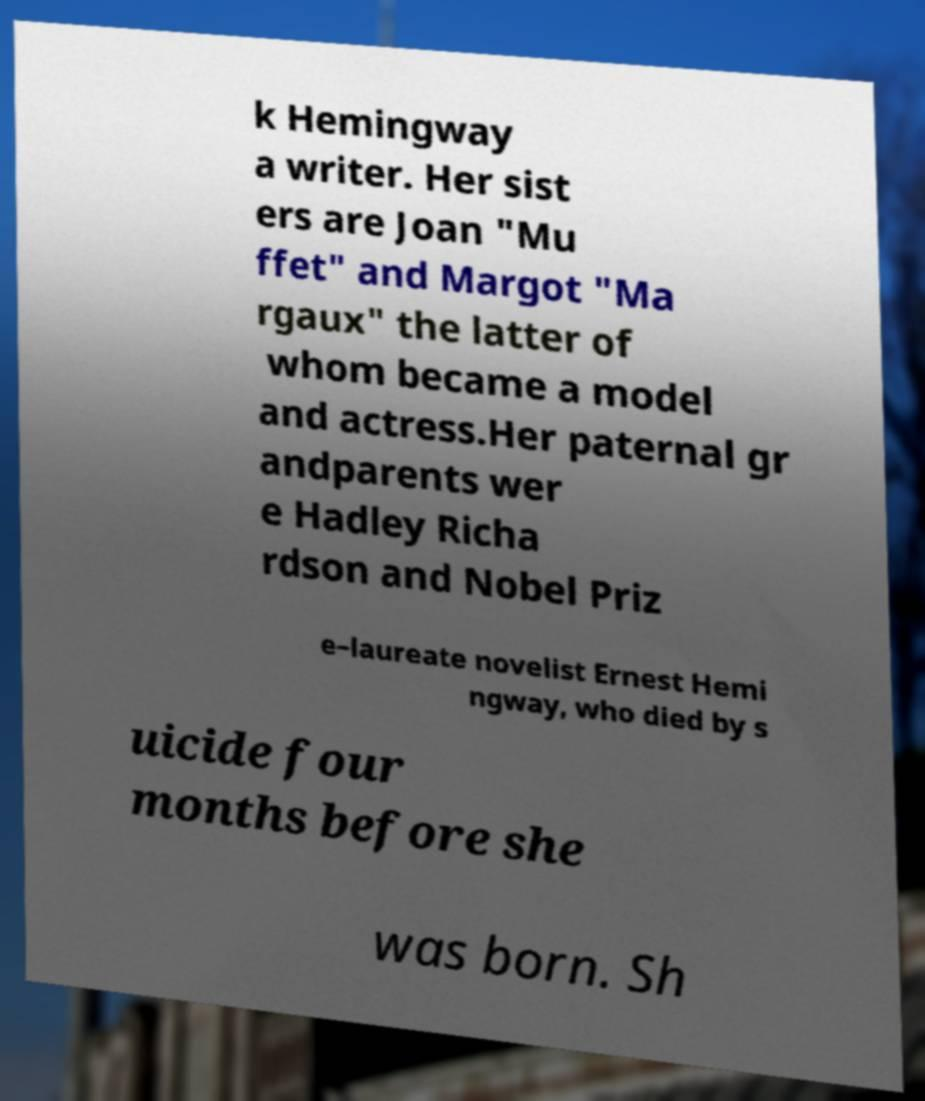For documentation purposes, I need the text within this image transcribed. Could you provide that? k Hemingway a writer. Her sist ers are Joan "Mu ffet" and Margot "Ma rgaux" the latter of whom became a model and actress.Her paternal gr andparents wer e Hadley Richa rdson and Nobel Priz e–laureate novelist Ernest Hemi ngway, who died by s uicide four months before she was born. Sh 